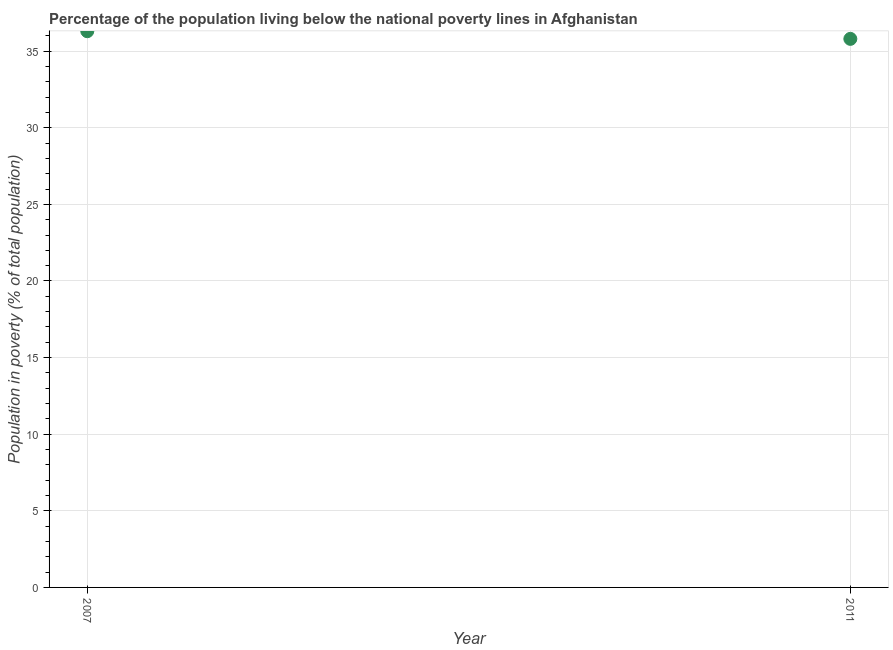What is the percentage of population living below poverty line in 2007?
Provide a succinct answer. 36.3. Across all years, what is the maximum percentage of population living below poverty line?
Offer a very short reply. 36.3. Across all years, what is the minimum percentage of population living below poverty line?
Make the answer very short. 35.8. In which year was the percentage of population living below poverty line minimum?
Your response must be concise. 2011. What is the sum of the percentage of population living below poverty line?
Your answer should be very brief. 72.1. What is the average percentage of population living below poverty line per year?
Keep it short and to the point. 36.05. What is the median percentage of population living below poverty line?
Offer a terse response. 36.05. In how many years, is the percentage of population living below poverty line greater than 35 %?
Give a very brief answer. 2. What is the ratio of the percentage of population living below poverty line in 2007 to that in 2011?
Make the answer very short. 1.01. Is the percentage of population living below poverty line in 2007 less than that in 2011?
Ensure brevity in your answer.  No. How many dotlines are there?
Provide a short and direct response. 1. How many years are there in the graph?
Provide a short and direct response. 2. What is the title of the graph?
Provide a short and direct response. Percentage of the population living below the national poverty lines in Afghanistan. What is the label or title of the X-axis?
Your answer should be very brief. Year. What is the label or title of the Y-axis?
Your response must be concise. Population in poverty (% of total population). What is the Population in poverty (% of total population) in 2007?
Provide a short and direct response. 36.3. What is the Population in poverty (% of total population) in 2011?
Keep it short and to the point. 35.8. What is the difference between the Population in poverty (% of total population) in 2007 and 2011?
Provide a succinct answer. 0.5. 